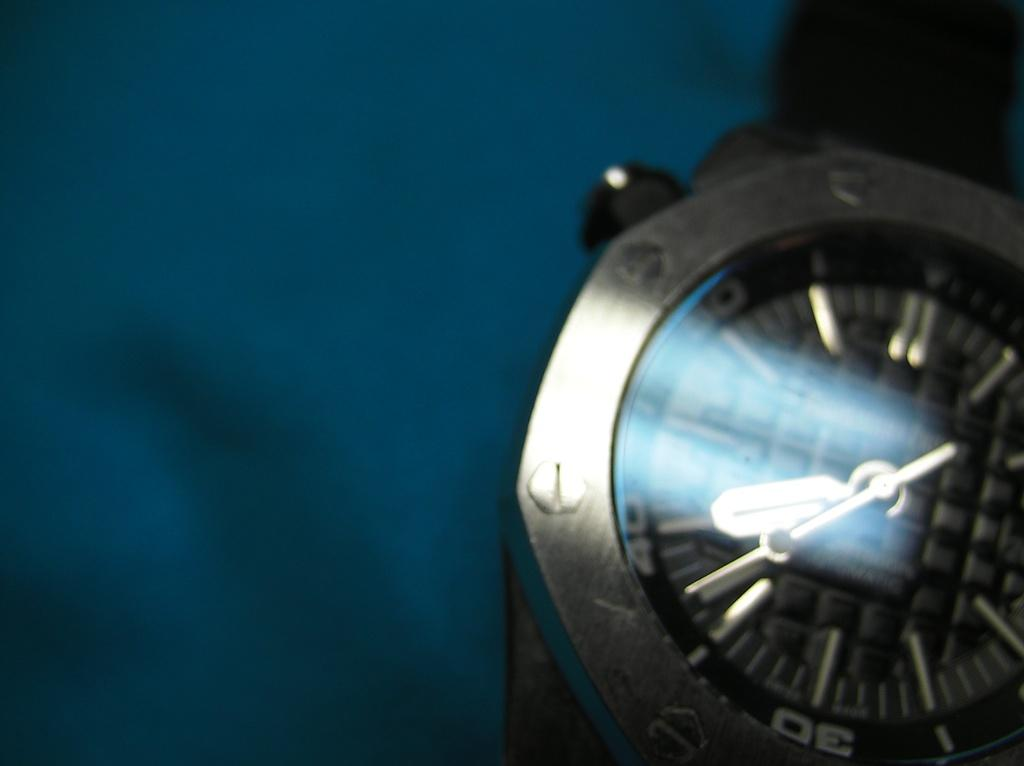Provide a one-sentence caption for the provided image. A silver wrist watch has the hour numbers marked my tens rather than by single digits. 